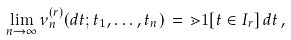Convert formula to latex. <formula><loc_0><loc_0><loc_500><loc_500>\lim _ { n \to \infty } \nu _ { n } ^ { ( r ) } ( d t ; t _ { 1 } , \dots , t _ { n } ) \, = \, \mathbb { m } { 1 } [ t \in I _ { r } ] \, d t \, ,</formula> 